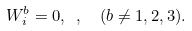<formula> <loc_0><loc_0><loc_500><loc_500>W _ { i } ^ { b } = 0 , \ , \ \ ( b \ne 1 , 2 , 3 ) .</formula> 